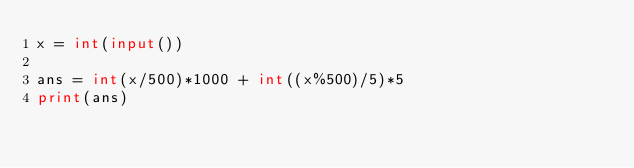<code> <loc_0><loc_0><loc_500><loc_500><_Python_>x = int(input())

ans = int(x/500)*1000 + int((x%500)/5)*5
print(ans)
</code> 